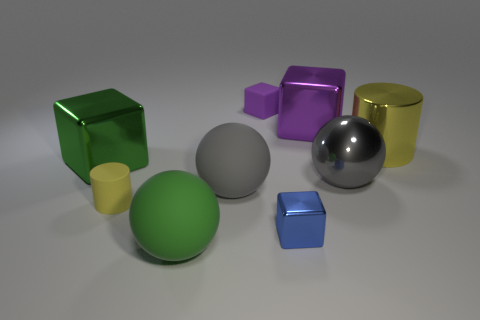There is a object that is both behind the yellow shiny cylinder and to the right of the small blue metal cube; what material is it?
Your answer should be compact. Metal. Are the big green sphere and the purple block that is on the right side of the small purple cube made of the same material?
Your response must be concise. No. How many things are small objects or cylinders on the left side of the green matte object?
Keep it short and to the point. 3. There is a metal cube behind the large green metallic cube; does it have the same size as the sphere on the right side of the big purple thing?
Give a very brief answer. Yes. How many other things are there of the same color as the tiny rubber cube?
Your response must be concise. 1. Does the green matte thing have the same size as the purple thing that is to the right of the tiny purple object?
Provide a succinct answer. Yes. What size is the sphere in front of the matte ball to the right of the green rubber sphere?
Provide a short and direct response. Large. There is a matte thing that is the same shape as the small blue metal object; what color is it?
Ensure brevity in your answer.  Purple. Do the gray metal sphere and the matte block have the same size?
Provide a short and direct response. No. Are there the same number of small matte cylinders to the right of the blue metallic thing and small blue matte objects?
Ensure brevity in your answer.  Yes. 